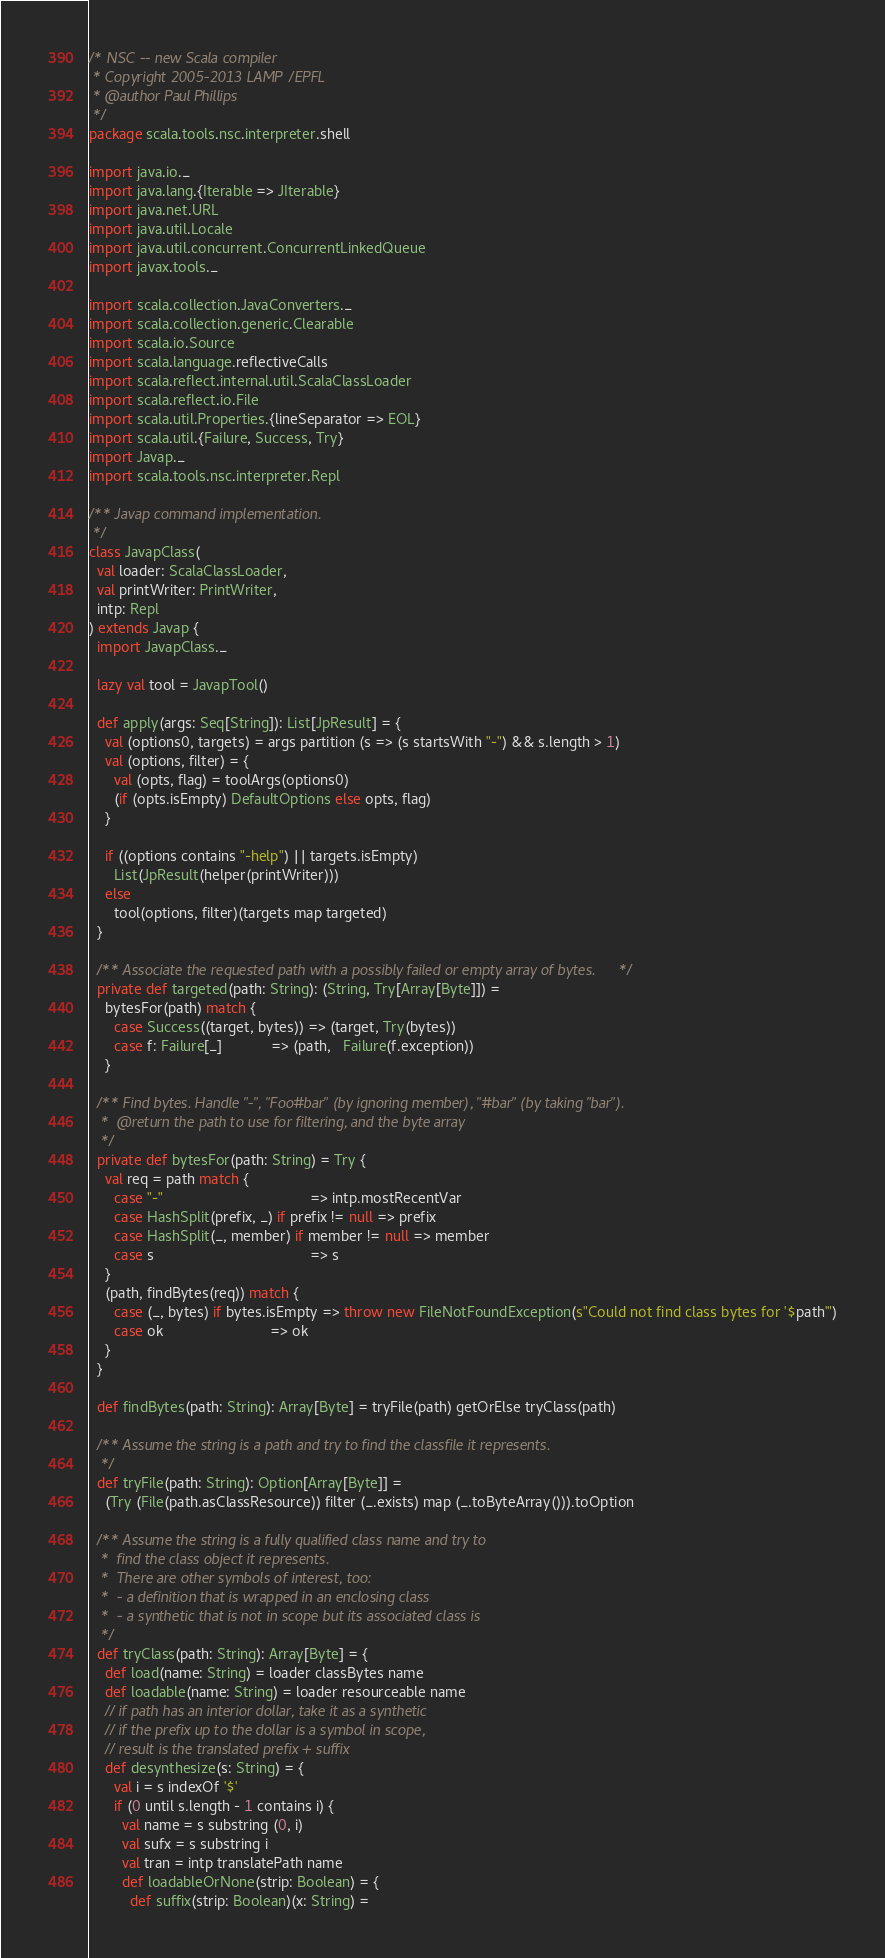<code> <loc_0><loc_0><loc_500><loc_500><_Scala_>/* NSC -- new Scala compiler
 * Copyright 2005-2013 LAMP/EPFL
 * @author Paul Phillips
 */
package scala.tools.nsc.interpreter.shell

import java.io._
import java.lang.{Iterable => JIterable}
import java.net.URL
import java.util.Locale
import java.util.concurrent.ConcurrentLinkedQueue
import javax.tools._

import scala.collection.JavaConverters._
import scala.collection.generic.Clearable
import scala.io.Source
import scala.language.reflectiveCalls
import scala.reflect.internal.util.ScalaClassLoader
import scala.reflect.io.File
import scala.util.Properties.{lineSeparator => EOL}
import scala.util.{Failure, Success, Try}
import Javap._
import scala.tools.nsc.interpreter.Repl

/** Javap command implementation.
 */
class JavapClass(
  val loader: ScalaClassLoader,
  val printWriter: PrintWriter,
  intp: Repl
) extends Javap {
  import JavapClass._

  lazy val tool = JavapTool()

  def apply(args: Seq[String]): List[JpResult] = {
    val (options0, targets) = args partition (s => (s startsWith "-") && s.length > 1)
    val (options, filter) = {
      val (opts, flag) = toolArgs(options0)
      (if (opts.isEmpty) DefaultOptions else opts, flag)
    }

    if ((options contains "-help") || targets.isEmpty)
      List(JpResult(helper(printWriter)))
    else
      tool(options, filter)(targets map targeted)
  }

  /** Associate the requested path with a possibly failed or empty array of bytes. */
  private def targeted(path: String): (String, Try[Array[Byte]]) =
    bytesFor(path) match {
      case Success((target, bytes)) => (target, Try(bytes))
      case f: Failure[_]            => (path,   Failure(f.exception))
    }

  /** Find bytes. Handle "-", "Foo#bar" (by ignoring member), "#bar" (by taking "bar").
   *  @return the path to use for filtering, and the byte array
   */
  private def bytesFor(path: String) = Try {
    val req = path match {
      case "-"                                    => intp.mostRecentVar
      case HashSplit(prefix, _) if prefix != null => prefix
      case HashSplit(_, member) if member != null => member
      case s                                      => s
    }
    (path, findBytes(req)) match {
      case (_, bytes) if bytes.isEmpty => throw new FileNotFoundException(s"Could not find class bytes for '$path'")
      case ok                          => ok
    }
  }

  def findBytes(path: String): Array[Byte] = tryFile(path) getOrElse tryClass(path)

  /** Assume the string is a path and try to find the classfile it represents.
   */
  def tryFile(path: String): Option[Array[Byte]] =
    (Try (File(path.asClassResource)) filter (_.exists) map (_.toByteArray())).toOption

  /** Assume the string is a fully qualified class name and try to
   *  find the class object it represents.
   *  There are other symbols of interest, too:
   *  - a definition that is wrapped in an enclosing class
   *  - a synthetic that is not in scope but its associated class is
   */
  def tryClass(path: String): Array[Byte] = {
    def load(name: String) = loader classBytes name
    def loadable(name: String) = loader resourceable name
    // if path has an interior dollar, take it as a synthetic
    // if the prefix up to the dollar is a symbol in scope,
    // result is the translated prefix + suffix
    def desynthesize(s: String) = {
      val i = s indexOf '$'
      if (0 until s.length - 1 contains i) {
        val name = s substring (0, i)
        val sufx = s substring i
        val tran = intp translatePath name
        def loadableOrNone(strip: Boolean) = {
          def suffix(strip: Boolean)(x: String) =</code> 